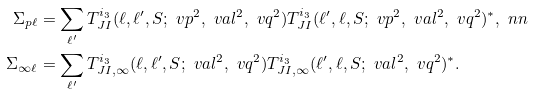<formula> <loc_0><loc_0><loc_500><loc_500>\Sigma _ { p \ell } & = \sum _ { \ell ^ { \prime } } T _ { J I } ^ { i _ { 3 } } ( \ell , \ell ^ { \prime } , S ; \ v p ^ { 2 } , \ v a l ^ { 2 } , \ v q ^ { 2 } ) T _ { J I } ^ { i _ { 3 } } ( \ell ^ { \prime } , \ell , S ; \ v p ^ { 2 } , \ v a l ^ { 2 } , \ v q ^ { 2 } ) ^ { * } , \ n n \\ \Sigma _ { \infty \ell } & = \sum _ { \ell ^ { \prime } } T _ { J I , \infty } ^ { i _ { 3 } } ( \ell , \ell ^ { \prime } , S ; \ v a l ^ { 2 } , \ v q ^ { 2 } ) T _ { J I , \infty } ^ { i _ { 3 } } ( \ell ^ { \prime } , \ell , S ; \ v a l ^ { 2 } , \ v q ^ { 2 } ) ^ { * } .</formula> 